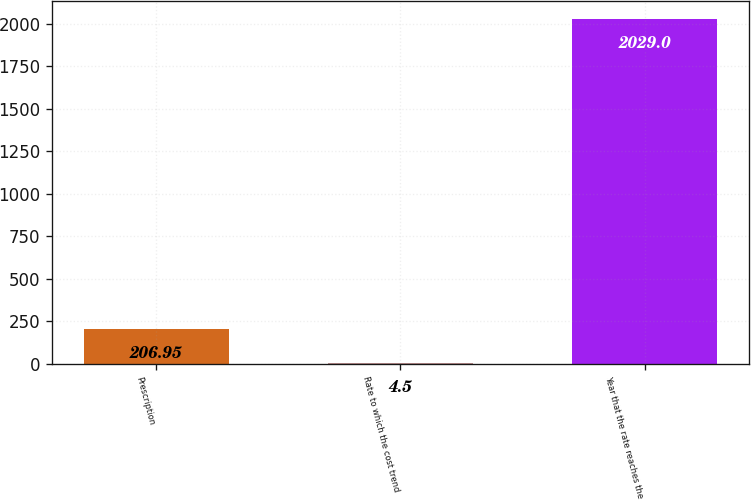Convert chart to OTSL. <chart><loc_0><loc_0><loc_500><loc_500><bar_chart><fcel>Prescription<fcel>Rate to which the cost trend<fcel>Year that the rate reaches the<nl><fcel>206.95<fcel>4.5<fcel>2029<nl></chart> 